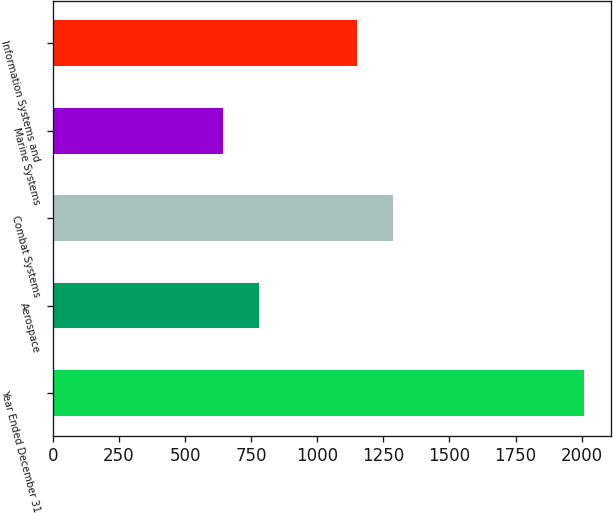<chart> <loc_0><loc_0><loc_500><loc_500><bar_chart><fcel>Year Ended December 31<fcel>Aerospace<fcel>Combat Systems<fcel>Marine Systems<fcel>Information Systems and<nl><fcel>2009<fcel>778.7<fcel>1287.7<fcel>642<fcel>1151<nl></chart> 